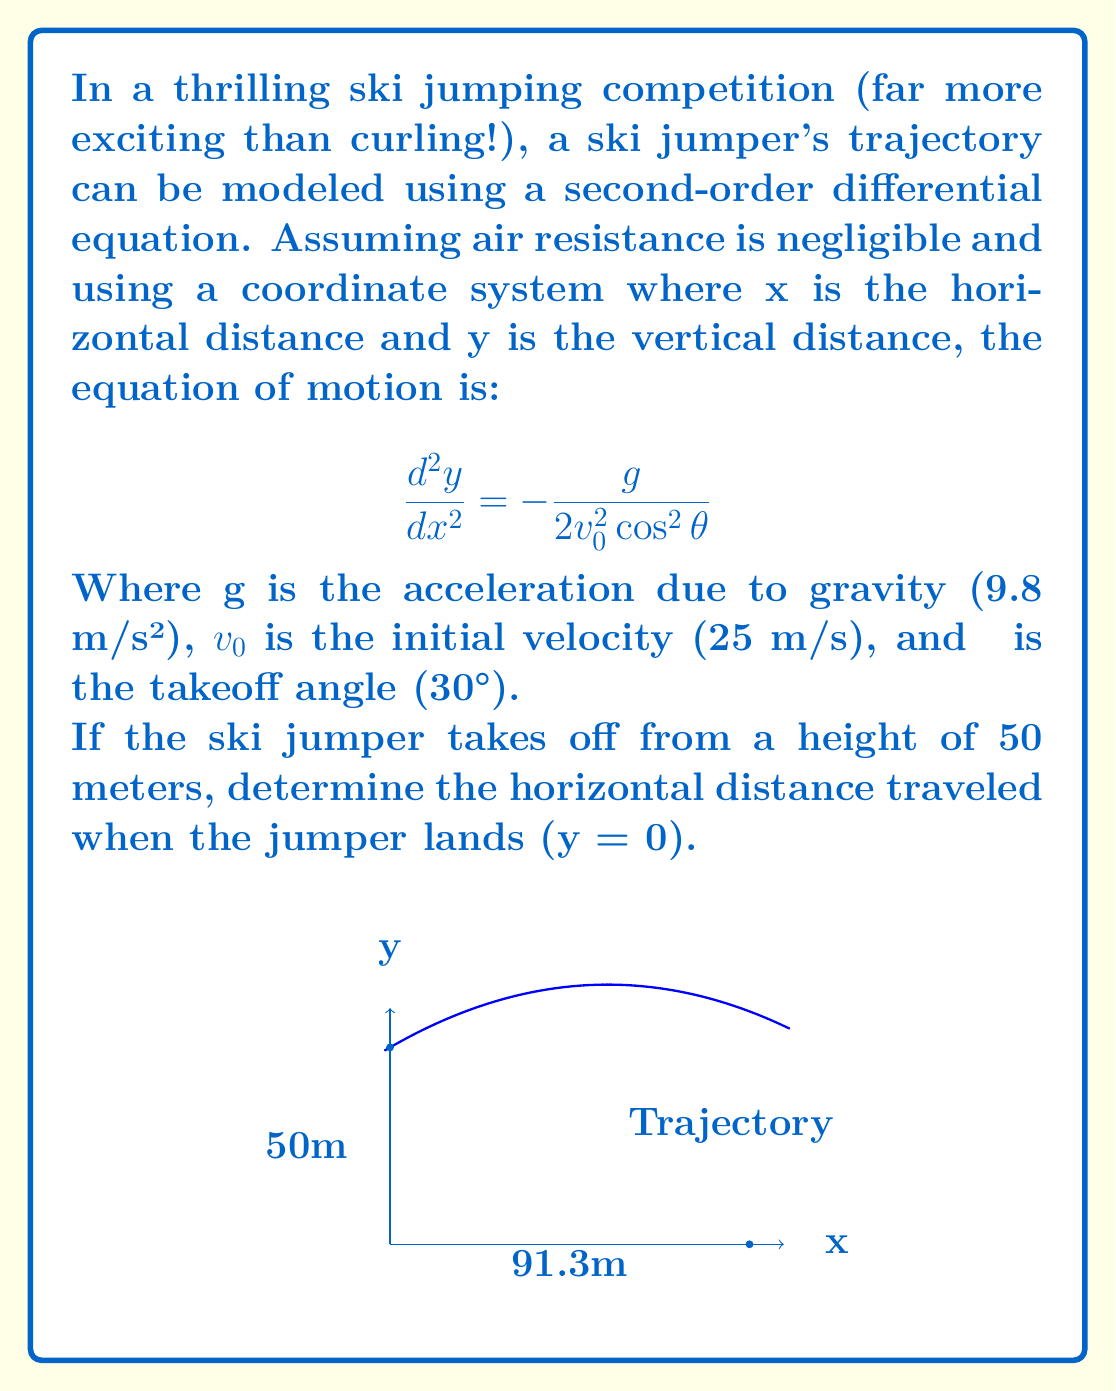Give your solution to this math problem. Let's solve this step-by-step:

1) The general solution to this differential equation is:

   $$y = x\tan\theta - \frac{g}{2v_0^2\cos^2\theta}\frac{x^2}{2} + C$$

2) We know the initial height (y = 50 when x = 0), so we can find C:

   $$50 = 0 + 0 + C$$
   $$C = 50$$

3) Therefore, the specific equation for this jump is:

   $$y = x\tan(30°) - \frac{9.8}{2(25^2)\cos^2(30°)}\frac{x^2}{2} + 50$$

4) Simplify:
   $$y = 0.577x - 0.0098x^2 + 50$$

5) To find where the jumper lands, we set y = 0 and solve for x:

   $$0 = 0.577x - 0.0098x^2 + 50$$
   $$0.0098x^2 - 0.577x - 50 = 0$$

6) This is a quadratic equation. We can solve it using the quadratic formula:

   $$x = \frac{-b \pm \sqrt{b^2 - 4ac}}{2a}$$

   Where a = 0.0098, b = -0.577, and c = -50

7) Plugging in these values:

   $$x = \frac{0.577 \pm \sqrt{(-0.577)^2 - 4(0.0098)(-50)}}{2(0.0098)}$$

8) Solving this gives us two solutions: x ≈ -5.8 and x ≈ 91.3

9) Since negative distance doesn't make sense in this context, we take the positive solution.

Therefore, the ski jumper will land approximately 91.3 meters from the takeoff point.
Answer: 91.3 meters 